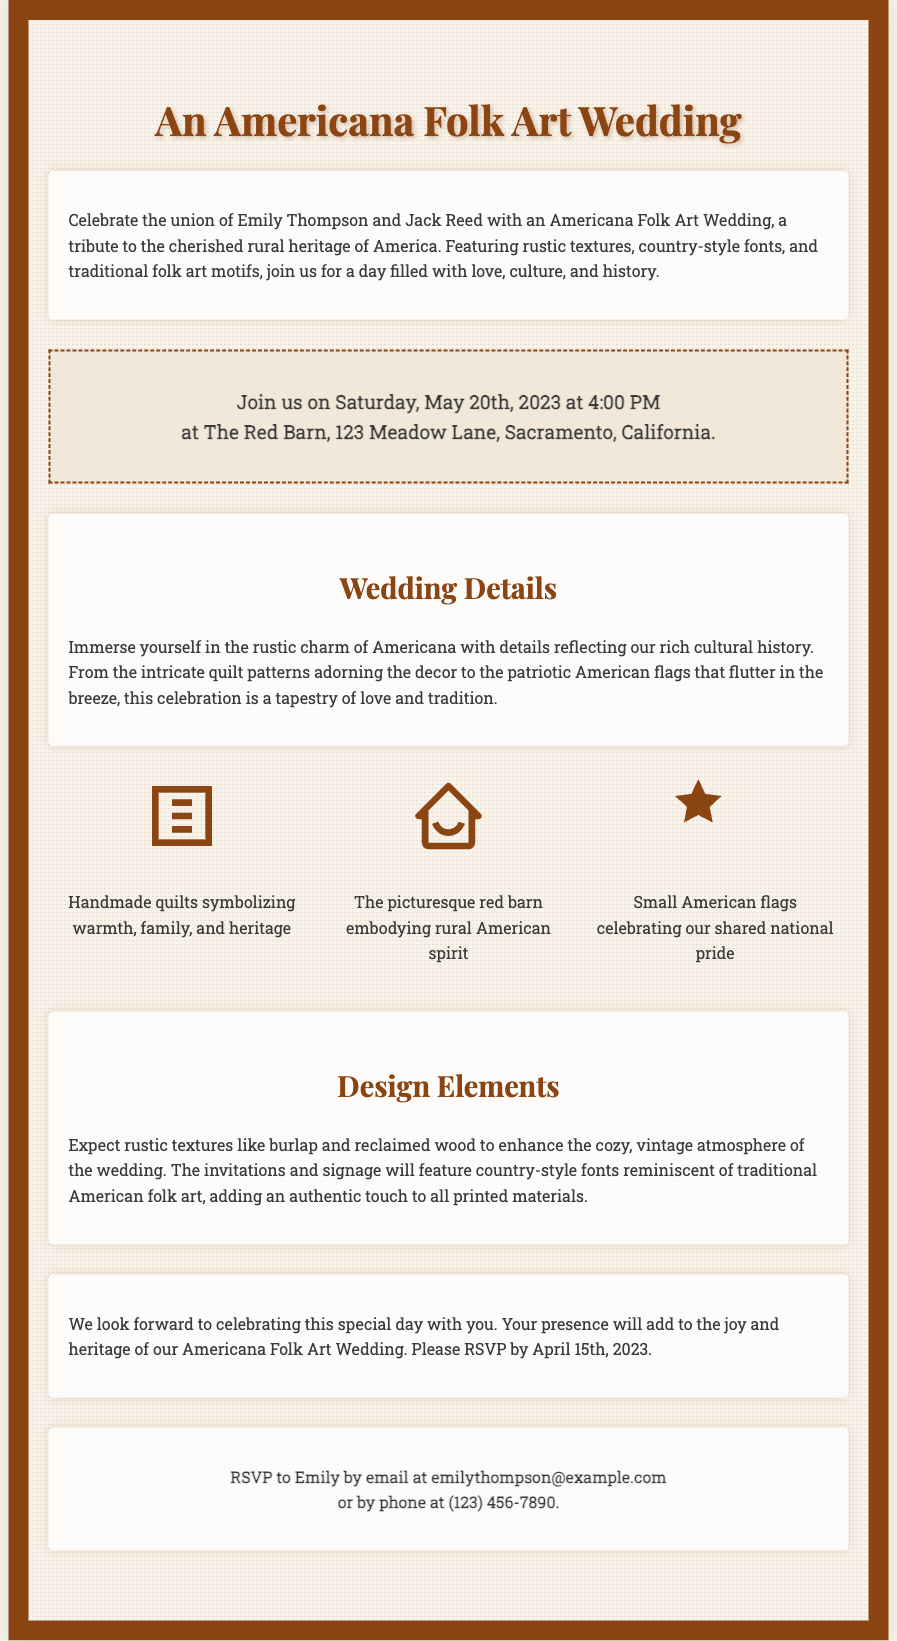What is the date of the wedding? The wedding is scheduled for Saturday, May 20th, 2023 as stated in the invitation.
Answer: May 20th, 2023 Who are the couple getting married? The invitation lists Emily Thompson and Jack Reed as the couple celebrating their wedding.
Answer: Emily Thompson and Jack Reed What is the location of the wedding? The wedding will take place at The Red Barn, 123 Meadow Lane, Sacramento, California, mentioned in the date-venue section.
Answer: The Red Barn, 123 Meadow Lane, Sacramento, California What is the RSVP deadline? The invitation specifies that the RSVP should be made by April 15th, 2023.
Answer: April 15th, 2023 What motifs are included in the wedding design? The document describes motifs including quilts, barns, and American flags, as key design elements representing rural heritage.
Answer: Quilts, barns, American flags 